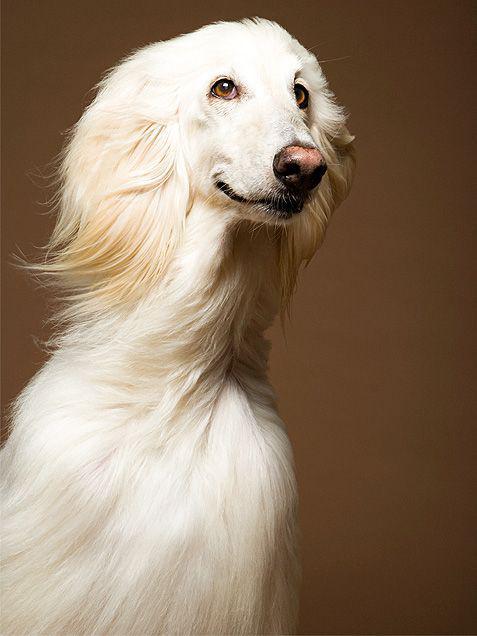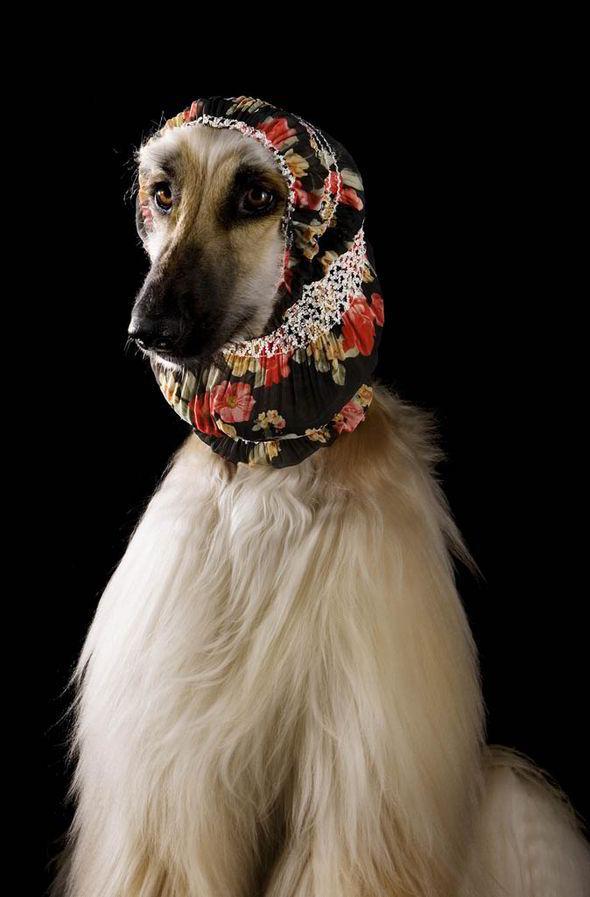The first image is the image on the left, the second image is the image on the right. Assess this claim about the two images: "An image includes a dog wearing something that covers its neck and the top of its head.". Correct or not? Answer yes or no. Yes. The first image is the image on the left, the second image is the image on the right. Evaluate the accuracy of this statement regarding the images: "In one image, one or more dogs with a long snout and black nose is wearing a head covering that extends down the neck, while a single dog in the second image is bareheaded.". Is it true? Answer yes or no. Yes. 